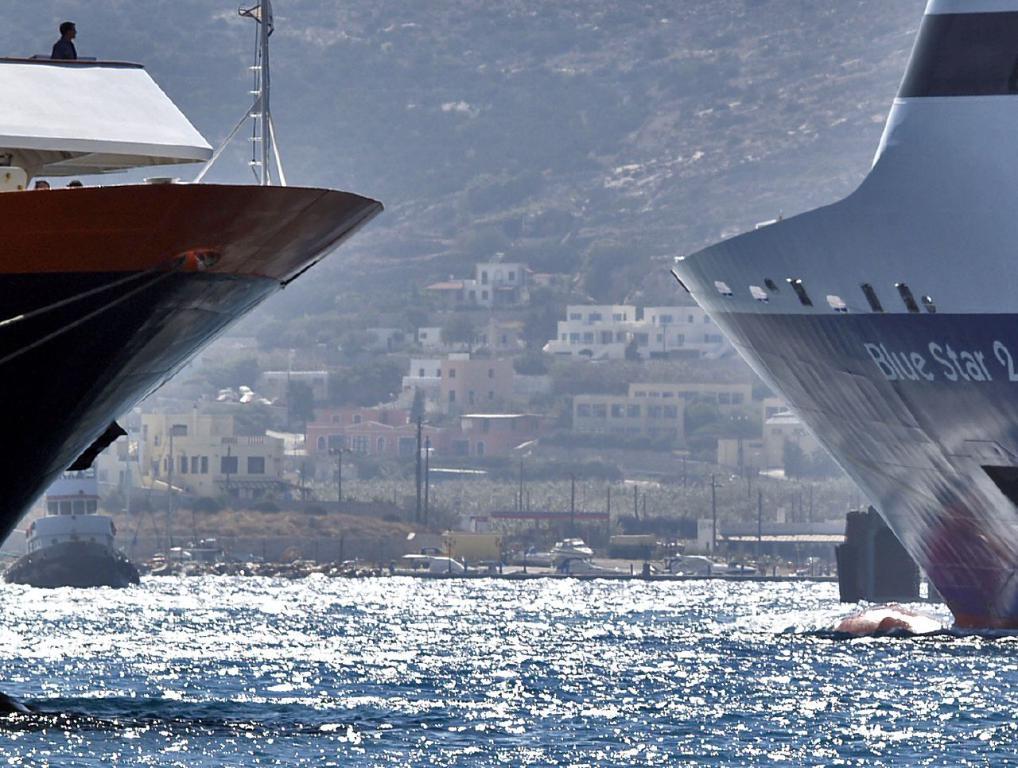What color star is the ship on the right named after?
Your answer should be very brief. Blue. 